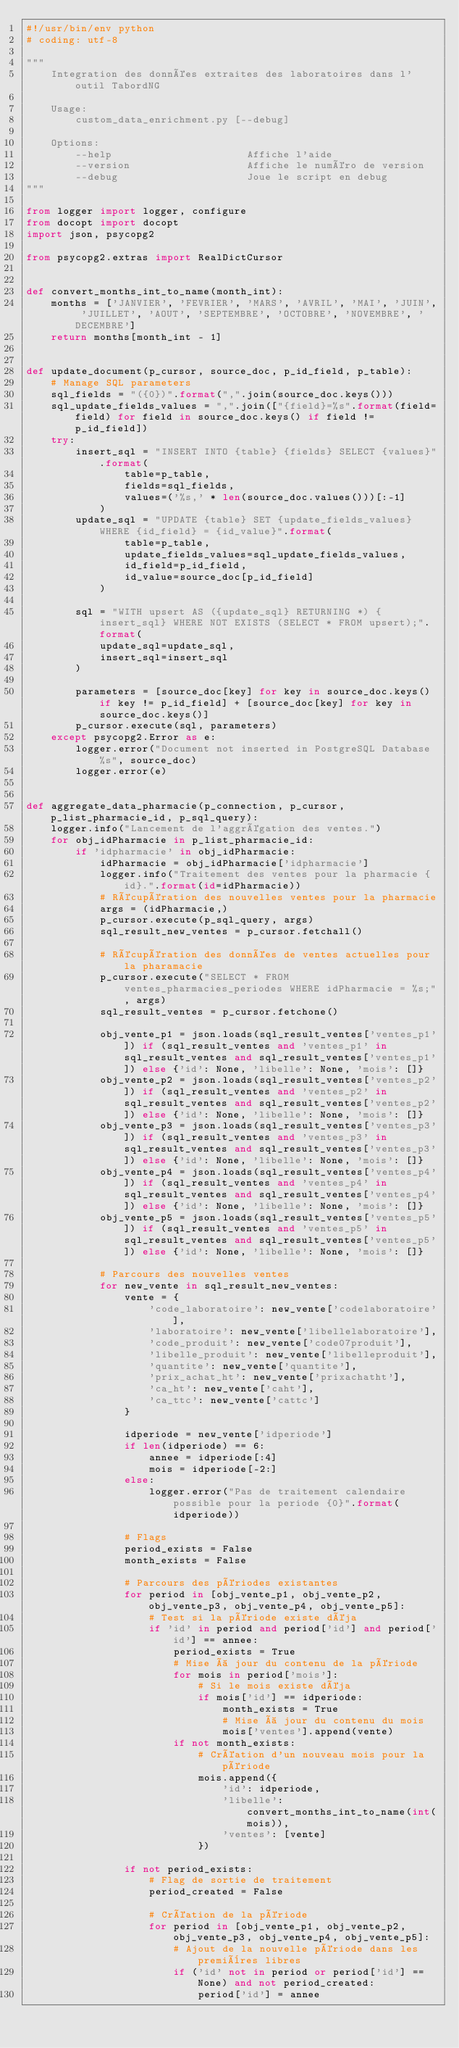Convert code to text. <code><loc_0><loc_0><loc_500><loc_500><_Python_>#!/usr/bin/env python
# coding: utf-8

""" 
    Integration des données extraites des laboratoires dans l'outil TabordNG

    Usage:
        custom_data_enrichment.py [--debug]

    Options:
        --help                      Affiche l'aide
        --version                   Affiche le numéro de version
        --debug                     Joue le script en debug
"""

from logger import logger, configure
from docopt import docopt
import json, psycopg2

from psycopg2.extras import RealDictCursor


def convert_months_int_to_name(month_int):
    months = ['JANVIER', 'FEVRIER', 'MARS', 'AVRIL', 'MAI', 'JUIN', 'JUILLET', 'AOUT', 'SEPTEMBRE', 'OCTOBRE', 'NOVEMBRE', 'DECEMBRE']
    return months[month_int - 1]


def update_document(p_cursor, source_doc, p_id_field, p_table):
    # Manage SQL parameters
    sql_fields = "({0})".format(",".join(source_doc.keys()))
    sql_update_fields_values = ",".join(["{field}=%s".format(field=field) for field in source_doc.keys() if field != p_id_field])
    try:
        insert_sql = "INSERT INTO {table} {fields} SELECT {values}".format(
                table=p_table,
                fields=sql_fields,
                values=('%s,' * len(source_doc.values()))[:-1]
            )
        update_sql = "UPDATE {table} SET {update_fields_values} WHERE {id_field} = {id_value}".format(
                table=p_table,
                update_fields_values=sql_update_fields_values,
                id_field=p_id_field,
                id_value=source_doc[p_id_field]
            )

        sql = "WITH upsert AS ({update_sql} RETURNING *) {insert_sql} WHERE NOT EXISTS (SELECT * FROM upsert);".format(
            update_sql=update_sql,
            insert_sql=insert_sql
        )
        
        parameters = [source_doc[key] for key in source_doc.keys() if key != p_id_field] + [source_doc[key] for key in source_doc.keys()]
        p_cursor.execute(sql, parameters)
    except psycopg2.Error as e:
        logger.error("Document not inserted in PostgreSQL Database %s", source_doc)
        logger.error(e)


def aggregate_data_pharmacie(p_connection, p_cursor, p_list_pharmacie_id, p_sql_query):
    logger.info("Lancement de l'aggrégation des ventes.")
    for obj_idPharmacie in p_list_pharmacie_id:
        if 'idpharmacie' in obj_idPharmacie:
            idPharmacie = obj_idPharmacie['idpharmacie']
            logger.info("Traitement des ventes pour la pharmacie {id}.".format(id=idPharmacie))
            # Récupération des nouvelles ventes pour la pharmacie
            args = (idPharmacie,)
            p_cursor.execute(p_sql_query, args)
            sql_result_new_ventes = p_cursor.fetchall()

            # Récupération des données de ventes actuelles pour la pharamacie
            p_cursor.execute("SELECT * FROM ventes_pharmacies_periodes WHERE idPharmacie = %s;", args)
            sql_result_ventes = p_cursor.fetchone()

            obj_vente_p1 = json.loads(sql_result_ventes['ventes_p1']) if (sql_result_ventes and 'ventes_p1' in sql_result_ventes and sql_result_ventes['ventes_p1']) else {'id': None, 'libelle': None, 'mois': []}
            obj_vente_p2 = json.loads(sql_result_ventes['ventes_p2']) if (sql_result_ventes and 'ventes_p2' in sql_result_ventes and sql_result_ventes['ventes_p2']) else {'id': None, 'libelle': None, 'mois': []}
            obj_vente_p3 = json.loads(sql_result_ventes['ventes_p3']) if (sql_result_ventes and 'ventes_p3' in sql_result_ventes and sql_result_ventes['ventes_p3']) else {'id': None, 'libelle': None, 'mois': []}
            obj_vente_p4 = json.loads(sql_result_ventes['ventes_p4']) if (sql_result_ventes and 'ventes_p4' in sql_result_ventes and sql_result_ventes['ventes_p4']) else {'id': None, 'libelle': None, 'mois': []}
            obj_vente_p5 = json.loads(sql_result_ventes['ventes_p5']) if (sql_result_ventes and 'ventes_p5' in sql_result_ventes and sql_result_ventes['ventes_p5']) else {'id': None, 'libelle': None, 'mois': []}

            # Parcours des nouvelles ventes
            for new_vente in sql_result_new_ventes:
                vente = {
                    'code_laboratoire': new_vente['codelaboratoire'],
                    'laboratoire': new_vente['libellelaboratoire'],
                    'code_produit': new_vente['code07produit'],
                    'libelle_produit': new_vente['libelleproduit'],
                    'quantite': new_vente['quantite'],
                    'prix_achat_ht': new_vente['prixachatht'],
                    'ca_ht': new_vente['caht'],
                    'ca_ttc': new_vente['cattc']
                }

                idperiode = new_vente['idperiode']
                if len(idperiode) == 6:
                    annee = idperiode[:4]
                    mois = idperiode[-2:]
                else:
                    logger.error("Pas de traitement calendaire possible pour la periode {0}".format(idperiode))

                # Flags
                period_exists = False
                month_exists = False
                
                # Parcours des périodes existantes
                for period in [obj_vente_p1, obj_vente_p2, obj_vente_p3, obj_vente_p4, obj_vente_p5]:
                    # Test si la période existe déja
                    if 'id' in period and period['id'] and period['id'] == annee:
                        period_exists = True
                        # Mise à jour du contenu de la période
                        for mois in period['mois']:
                            # Si le mois existe déja
                            if mois['id'] == idperiode:
                                month_exists = True
                                # Mise à jour du contenu du mois
                                mois['ventes'].append(vente)
                        if not month_exists:
                            # Création d'un nouveau mois pour la période
                            mois.append({
                                'id': idperiode,
                                'libelle': convert_months_int_to_name(int(mois)),
                                'ventes': [vente]
                            })
                
                if not period_exists:
                    # Flag de sortie de traitement
                    period_created = False
                
                    # Création de la période
                    for period in [obj_vente_p1, obj_vente_p2, obj_vente_p3, obj_vente_p4, obj_vente_p5]:
                        # Ajout de la nouvelle période dans les premières libres
                        if ('id' not in period or period['id'] == None) and not period_created:
                            period['id'] = annee</code> 